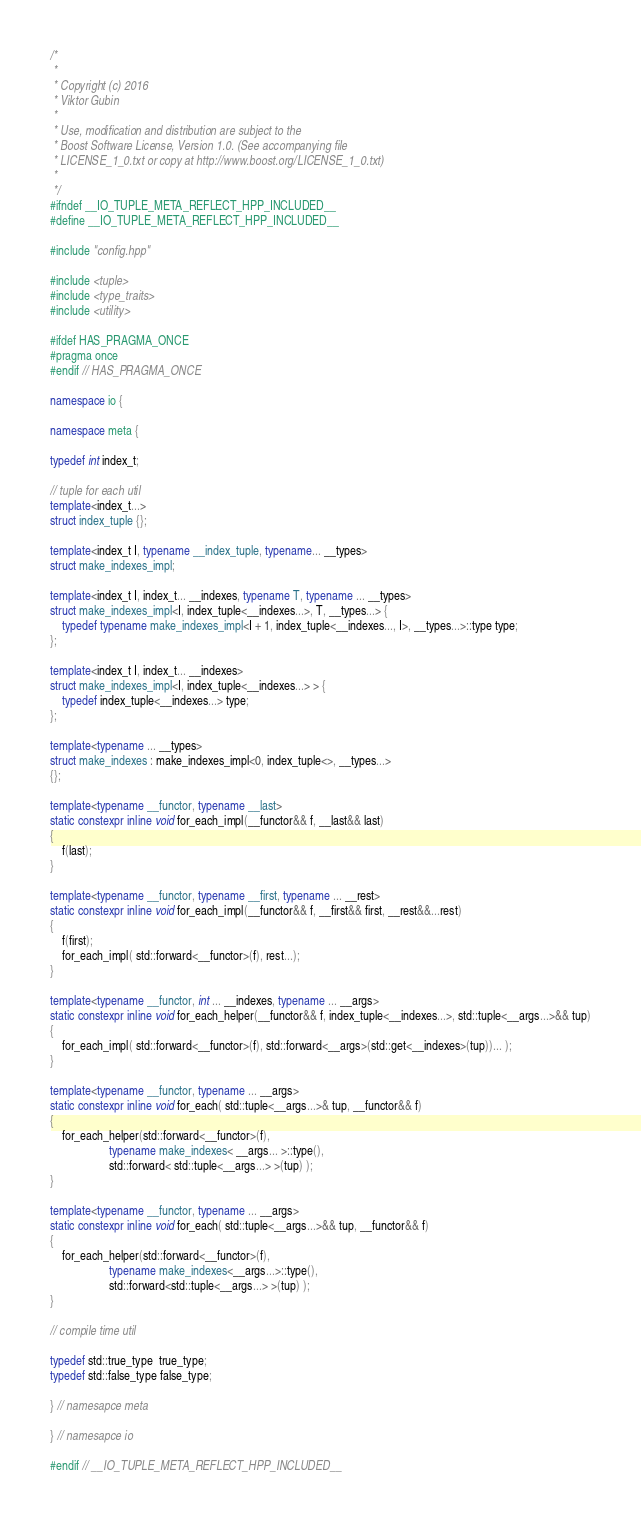Convert code to text. <code><loc_0><loc_0><loc_500><loc_500><_C++_>/*
 *
 * Copyright (c) 2016
 * Viktor Gubin
 *
 * Use, modification and distribution are subject to the
 * Boost Software License, Version 1.0. (See accompanying file
 * LICENSE_1_0.txt or copy at http://www.boost.org/LICENSE_1_0.txt)
 *
 */
#ifndef __IO_TUPLE_META_REFLECT_HPP_INCLUDED__
#define __IO_TUPLE_META_REFLECT_HPP_INCLUDED__

#include "config.hpp"

#include <tuple>
#include <type_traits>
#include <utility>

#ifdef HAS_PRAGMA_ONCE
#pragma once
#endif // HAS_PRAGMA_ONCE

namespace io {

namespace meta {

typedef int index_t;

// tuple for each util
template<index_t...>
struct index_tuple {};

template<index_t I, typename __index_tuple, typename... __types>
struct make_indexes_impl;

template<index_t I, index_t... __indexes, typename T, typename ... __types>
struct make_indexes_impl<I, index_tuple<__indexes...>, T, __types...> {
	typedef typename make_indexes_impl<I + 1, index_tuple<__indexes..., I>, __types...>::type type;
};

template<index_t I, index_t... __indexes>
struct make_indexes_impl<I, index_tuple<__indexes...> > {
	typedef index_tuple<__indexes...> type;
};

template<typename ... __types>
struct make_indexes : make_indexes_impl<0, index_tuple<>, __types...>
{};

template<typename __functor, typename __last>
static constexpr inline void for_each_impl(__functor&& f, __last&& last)
{
	f(last);
}

template<typename __functor, typename __first, typename ... __rest>
static constexpr inline void for_each_impl(__functor&& f, __first&& first, __rest&&...rest)
{
	f(first);
	for_each_impl( std::forward<__functor>(f), rest...);
}

template<typename __functor, int ... __indexes, typename ... __args>
static constexpr inline void for_each_helper(__functor&& f, index_tuple<__indexes...>, std::tuple<__args...>&& tup)
{
	for_each_impl( std::forward<__functor>(f), std::forward<__args>(std::get<__indexes>(tup))... );
}

template<typename __functor, typename ... __args>
static constexpr inline void for_each( std::tuple<__args...>& tup, __functor&& f)
{
	for_each_helper(std::forward<__functor>(f),
	                typename make_indexes< __args... >::type(),
	                std::forward< std::tuple<__args...> >(tup) );
}

template<typename __functor, typename ... __args>
static constexpr inline void for_each( std::tuple<__args...>&& tup, __functor&& f)
{
	for_each_helper(std::forward<__functor>(f),
	                typename make_indexes<__args...>::type(),
	                std::forward<std::tuple<__args...> >(tup) );
}

// compile time util

typedef std::true_type  true_type;
typedef std::false_type false_type;

} // namesapce meta

} // namesapce io

#endif // __IO_TUPLE_META_REFLECT_HPP_INCLUDED__
</code> 